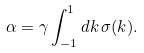Convert formula to latex. <formula><loc_0><loc_0><loc_500><loc_500>\alpha = \gamma \int _ { - 1 } ^ { 1 } d k \, \sigma ( k ) .</formula> 